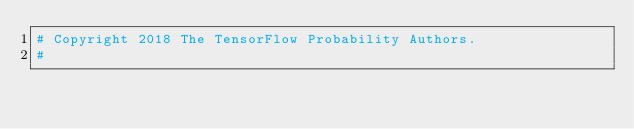Convert code to text. <code><loc_0><loc_0><loc_500><loc_500><_Python_># Copyright 2018 The TensorFlow Probability Authors.
#</code> 